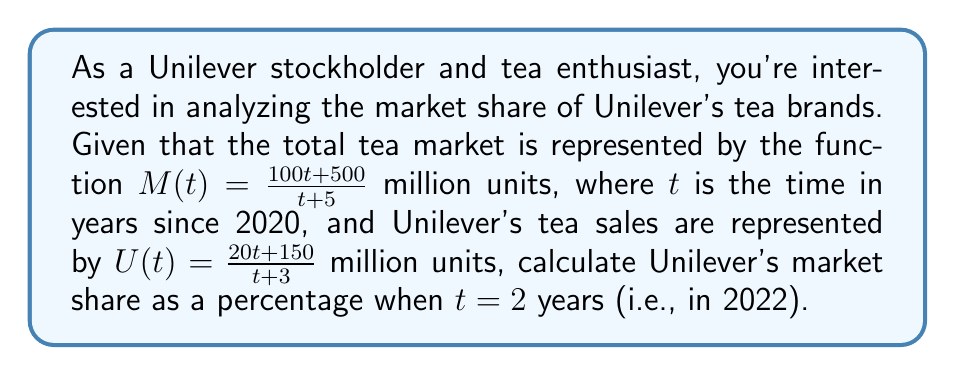Help me with this question. To calculate Unilever's market share as a percentage, we need to follow these steps:

1) First, let's calculate the total market size when $t = 2$:
   $$M(2) = \frac{100(2)+500}{2+5} = \frac{200+500}{7} = \frac{700}{7} \approx 100$$

2) Now, let's calculate Unilever's tea sales when $t = 2$:
   $$U(2) = \frac{20(2)+150}{2+3} = \frac{40+150}{5} = \frac{190}{5} = 38$$

3) To find the market share, we divide Unilever's sales by the total market size and multiply by 100:

   $$\text{Market Share} = \frac{U(2)}{M(2)} \times 100\%$$

4) Substituting the values:
   $$\text{Market Share} = \frac{38}{100} \times 100\% = 38\%$$

Therefore, Unilever's market share in 2022 is approximately 38%.
Answer: 38% 